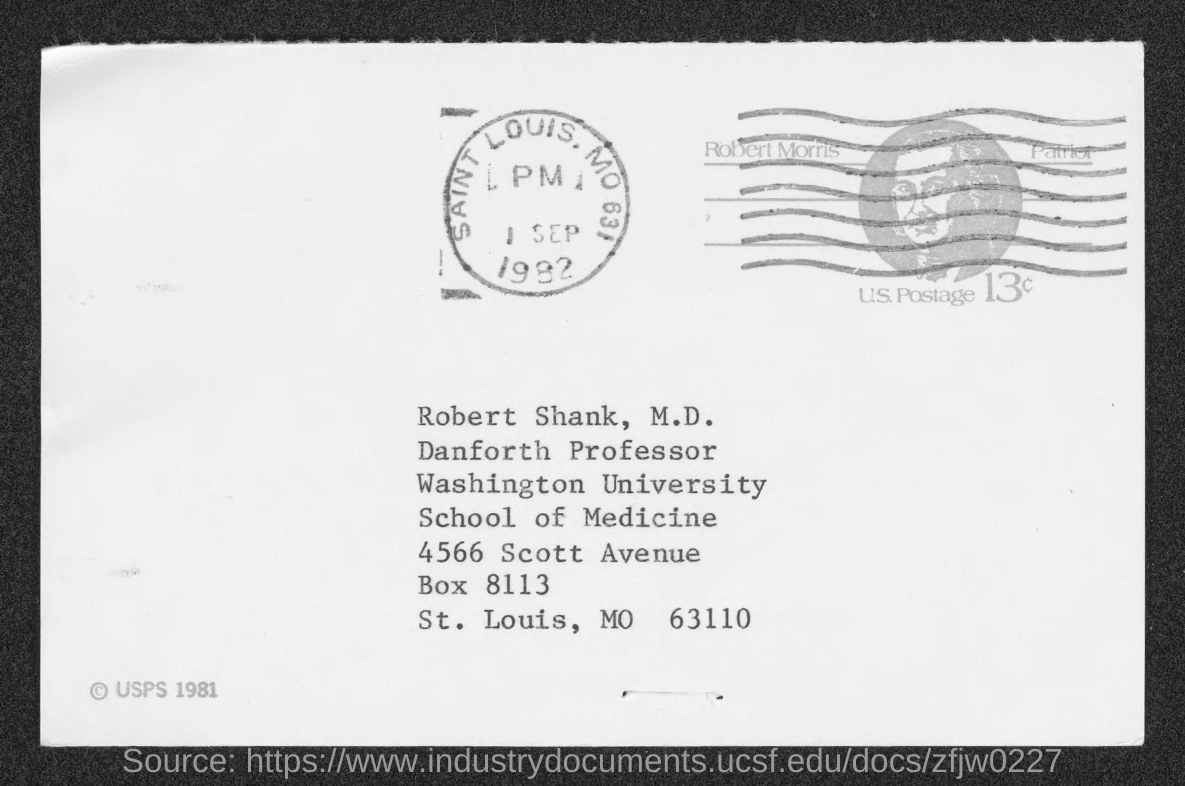Indicate a few pertinent items in this graphic. The date mentioned in the document is September 1, 1982. 